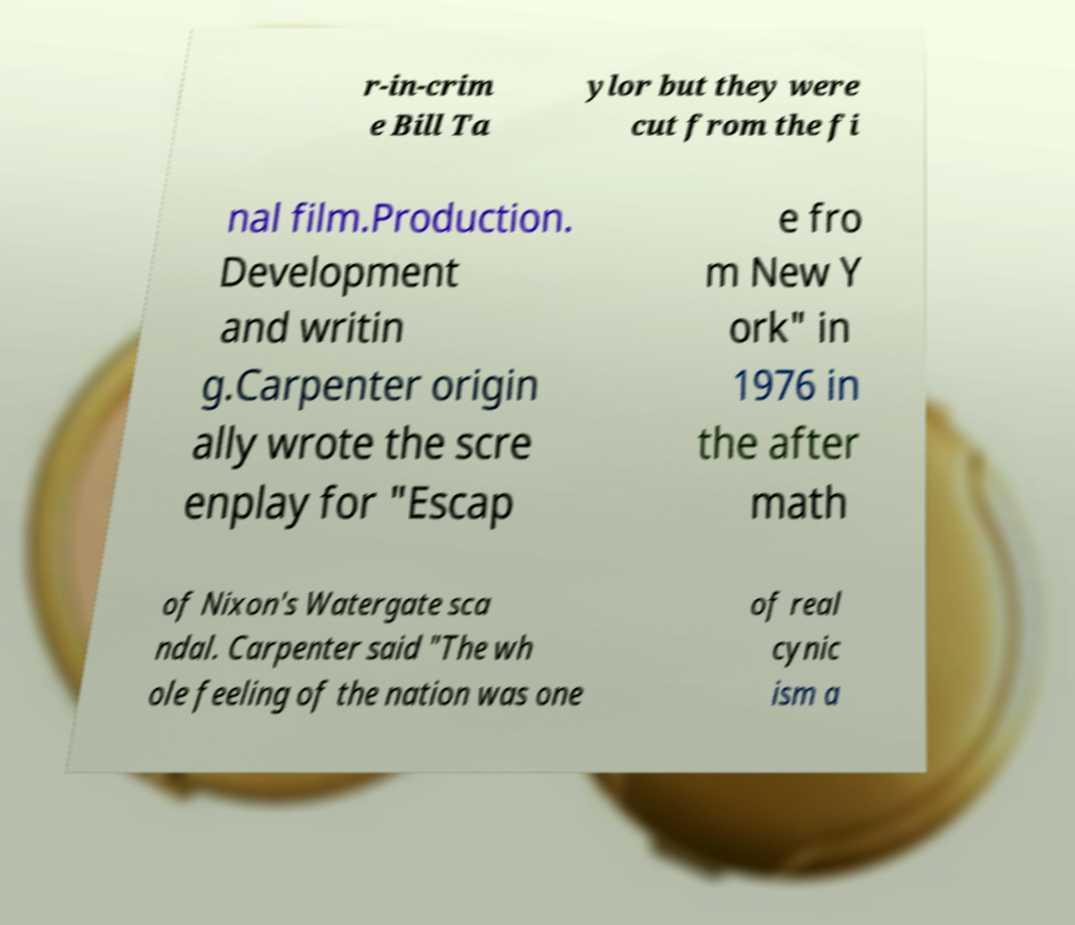Can you read and provide the text displayed in the image?This photo seems to have some interesting text. Can you extract and type it out for me? r-in-crim e Bill Ta ylor but they were cut from the fi nal film.Production. Development and writin g.Carpenter origin ally wrote the scre enplay for "Escap e fro m New Y ork" in 1976 in the after math of Nixon's Watergate sca ndal. Carpenter said "The wh ole feeling of the nation was one of real cynic ism a 